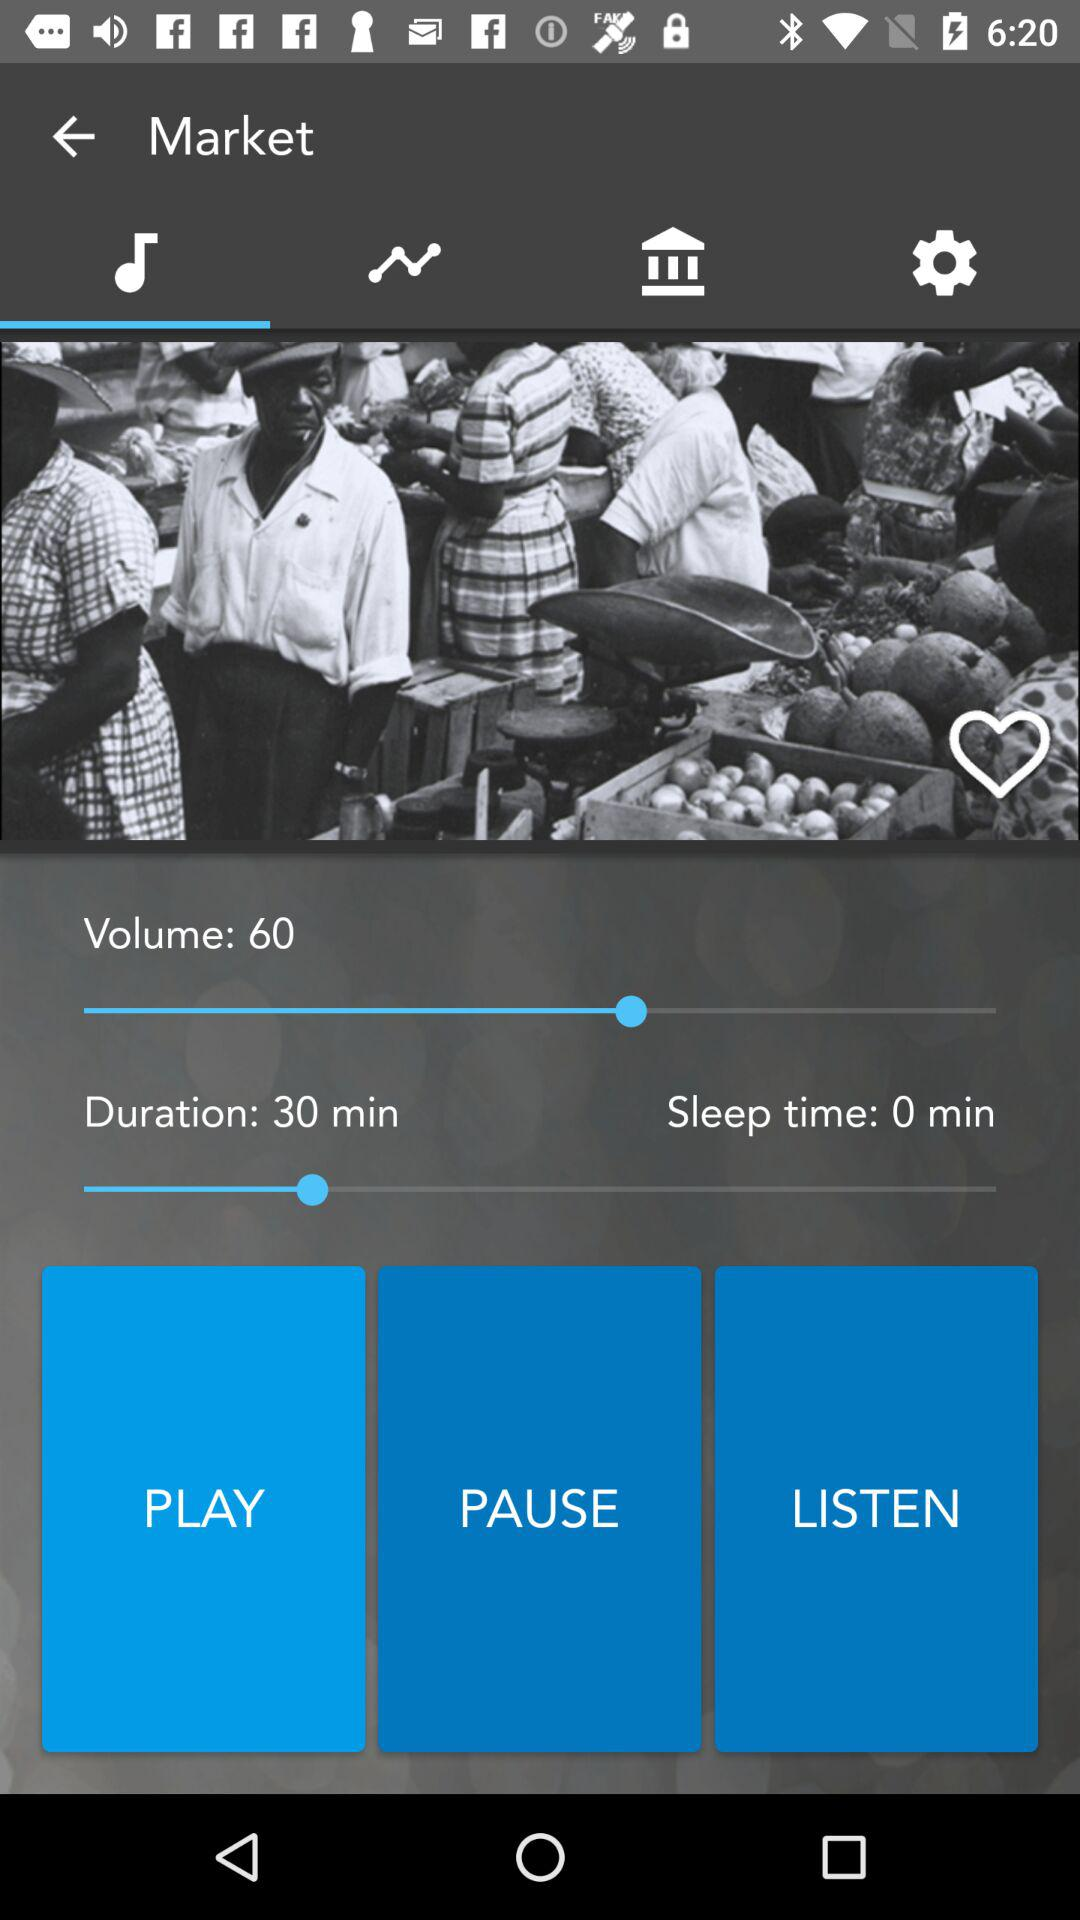What is the volume? The volume is 60. 